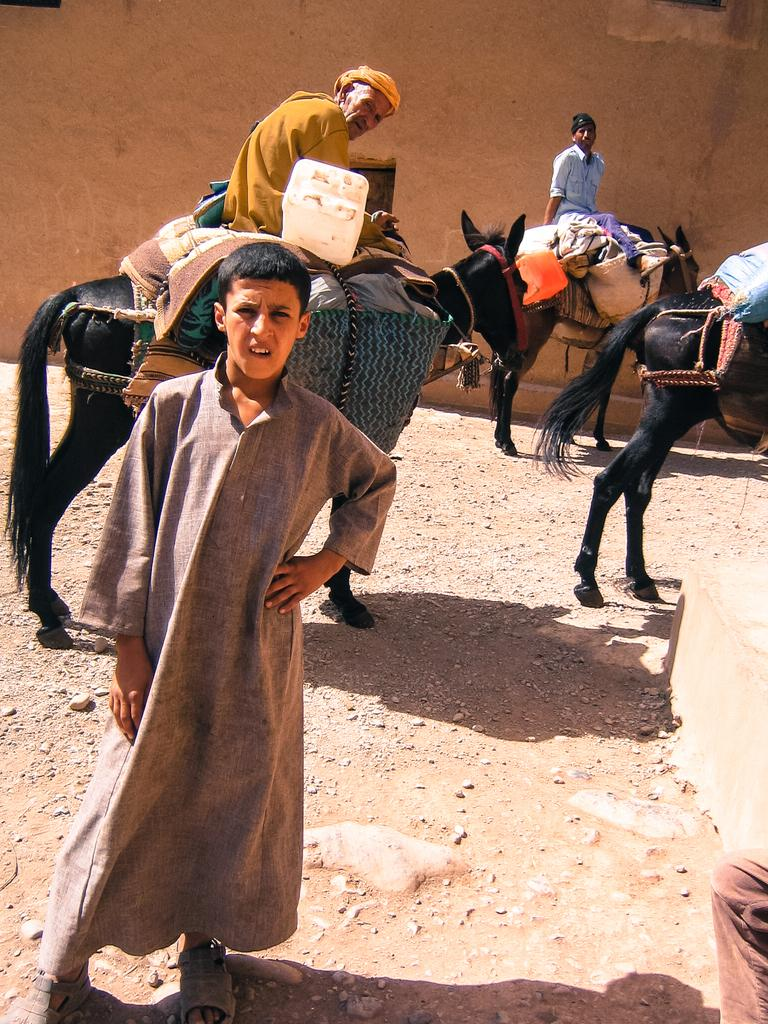How many people are in the image? There are two people in the image, both sitting on horses. What is the man standing in the image doing? The fact does not specify what the man standing is doing, but he is present in the image. How many horses are in the image? There are two horses in the image, with one person sitting on each. What can be seen in the background of the image? There is a wall in the background of the image. What type of whistle can be heard in the image? There is no whistle present in the image, and therefore no sound can be heard. Is there a zebra in the image? No, there is no zebra in the image; it features two people sitting on horses and a man standing nearby. 